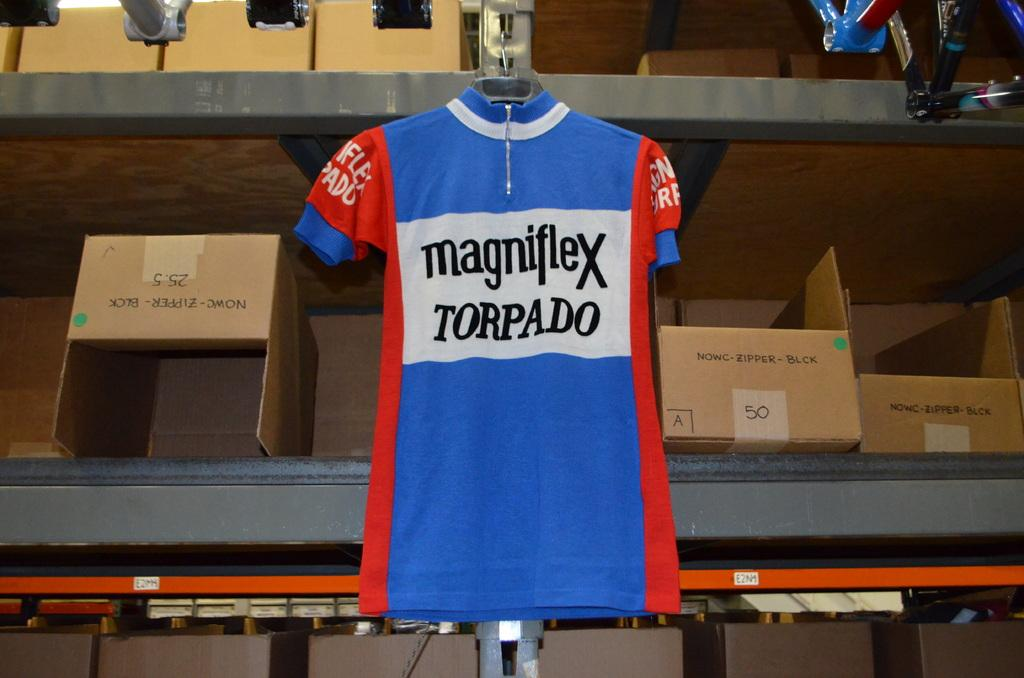<image>
Describe the image concisely. A blue, red and white shirt hanging on a hanger with the saying Magniflex Torapado on the front of the shirt. 